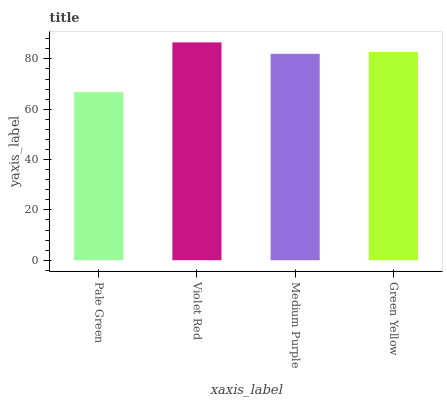Is Pale Green the minimum?
Answer yes or no. Yes. Is Violet Red the maximum?
Answer yes or no. Yes. Is Medium Purple the minimum?
Answer yes or no. No. Is Medium Purple the maximum?
Answer yes or no. No. Is Violet Red greater than Medium Purple?
Answer yes or no. Yes. Is Medium Purple less than Violet Red?
Answer yes or no. Yes. Is Medium Purple greater than Violet Red?
Answer yes or no. No. Is Violet Red less than Medium Purple?
Answer yes or no. No. Is Green Yellow the high median?
Answer yes or no. Yes. Is Medium Purple the low median?
Answer yes or no. Yes. Is Violet Red the high median?
Answer yes or no. No. Is Violet Red the low median?
Answer yes or no. No. 